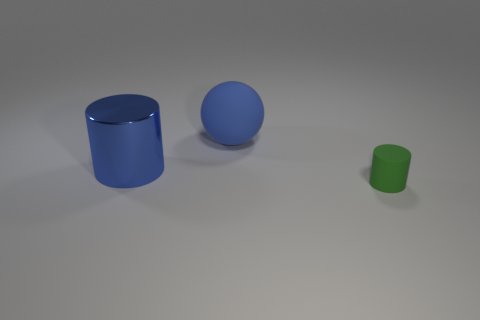What is the shape of the rubber object that is the same color as the large cylinder? The rubber object sharing the same color as the large cylinder is spherical in shape. This similarity in color between the two objects provides a pleasant visual coherence in this simple yet interesting composition. 